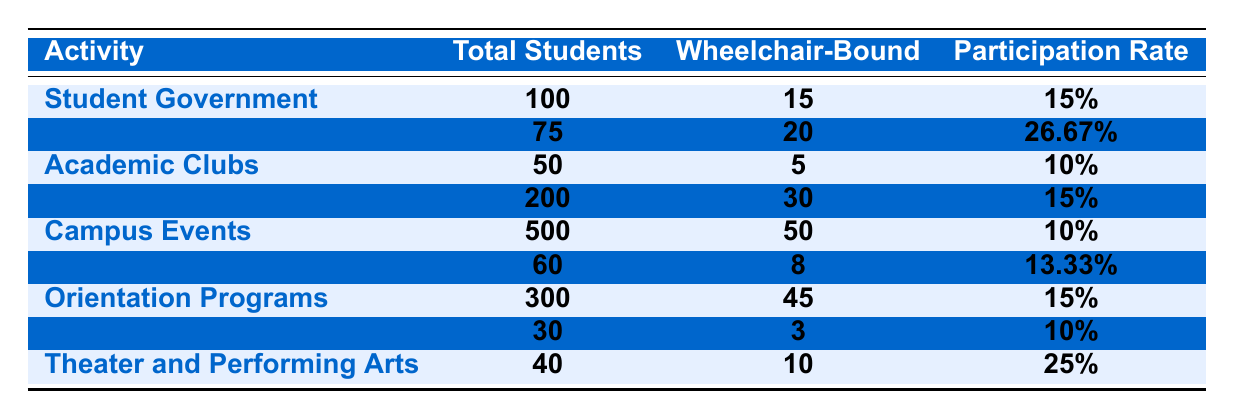What is the participation rate of wheelchair-bound students in Club Sports? The table specifies that the participation rate for Club Sports is listed as 26.67%.
Answer: 26.67% Which campus activity has the highest number of wheelchair-bound participants? By comparing the "Wheelchair-Bound" column, Club Sports has 20 participants, Volunteering Programs has 30 participants, which is the highest.
Answer: Volunteering Programs What percentage of wheelchair-bound students participate in the Academic Clubs? The table indicates that Academic Clubs have 5 wheelchair-bound participants out of a total of 50 students, reflected as a participation rate of 10%.
Answer: 10% How many total wheelchair-bound participants are there across all activities combined? Adding the wheelchair-bound participants in each activity: 15 (Student Government) + 20 (Club Sports) + 5 (Academic Clubs) + 30 (Volunteering Programs) + 50 (Campus Events) + 8 (Research Projects) + 45 (Orientation Programs) + 3 (Honor Societies) + 10 (Theater and Performing Arts) gives a total of 183.
Answer: 183 Is the participation rate in Orientation Programs higher than that in Campus Events? Orientation Programs have a participation rate of 15%, while Campus Events have a 10% rate. Thus, Orientation Programs have a higher participation rate.
Answer: Yes What is the average participation rate of wheelchair-bound students across all listed activities? The rates are: 15%, 26.67%, 10%, 15%, 10%, 13.33%, 15%, 10%, and 25%. To find the average, add these and divide by the number of activities (9): (15 + 26.67 + 10 + 15 + 10 + 13.33 + 15 + 10 + 25)/9 = 14.37%.
Answer: 14.37% Which activities have a participation rate of 10%? The table lists Academic Clubs, Campus Events, and Honor Societies as having a participation rate of 10%.
Answer: Academic Clubs, Campus Events, Honor Societies How many more wheelchair-bound participants are there in Research Projects compared to Academic Clubs? Research Projects have 8 wheelchair-bound participants, while Academic Clubs have 5, so the difference is 8 - 5 = 3.
Answer: 3 Does the data indicate that Theater and Performing Arts have a higher participation rate than Student Government? Theater and Performing Arts has a participation rate of 25%, while Student Government has a rate of 15%. Since 25% is greater than 15%, it does indicate that.
Answer: Yes What percentage of total students in Club Sports are wheelchair-bound participants? The table shows 20 out of 75 students in Club Sports are wheelchair-bound, which gives a participation rate calculated as (20/75) * 100 = 26.67%.
Answer: 26.67% 